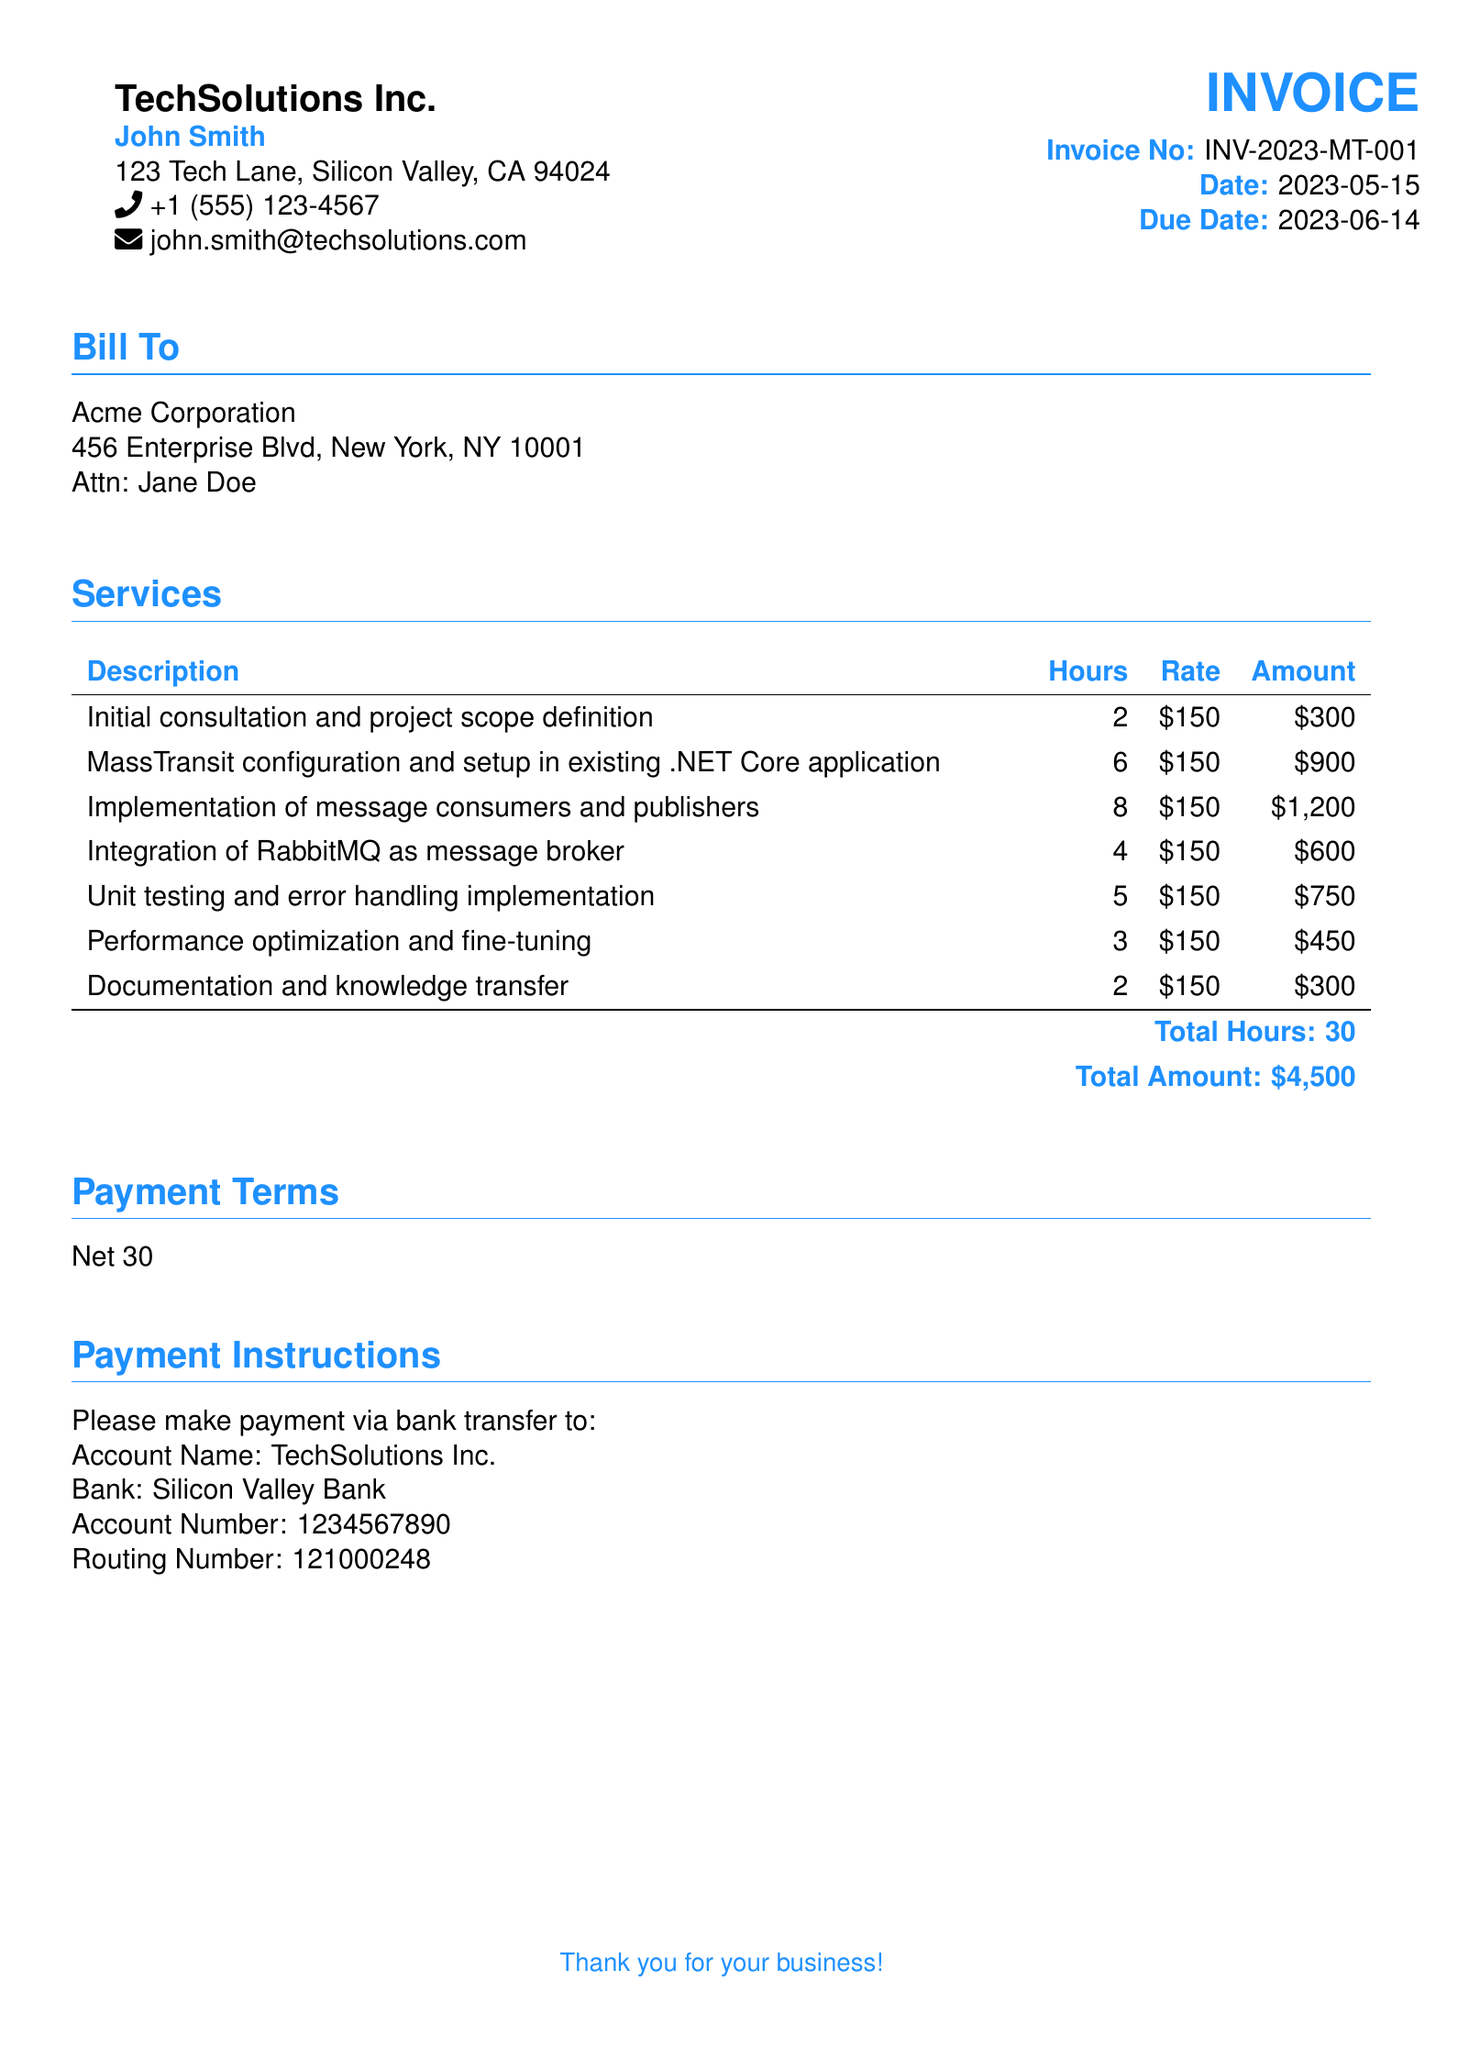What is the total amount? The total amount is explicitly stated in the document under the services section, which sums to four thousand five hundred dollars.
Answer: $4,500 Who is the contact person for Acme Corporation? The document specifies Jane Doe as the contact person for Acme Corporation in the "Bill To" section.
Answer: Jane Doe How many hours were spent on MassTransit configuration and setup? The hours for MassTransit configuration and setup are clearly listed in the services table as six hours.
Answer: 6 What is the invoice number? The invoice number is provided at the top of the document, which is used for tracking purposes; it reads INV-2023-MT-001.
Answer: INV-2023-MT-001 What is the due date for the invoice? The due date is mentioned near the top of the document and provides a timeframe for payment, specifically listing June 14, 2023.
Answer: 2023-06-14 Which service took the most hours to complete? By analyzing the services section, the implementation of message consumers and publishers is noted to take eight hours, the most compared to others.
Answer: Implementation of message consumers and publishers What payment terms are stated in the invoice? The document specifies the payment terms, which outline the duration until payment is due; it states Net 30.
Answer: Net 30 How many total hours were billed? The total hours are summed up in the services section of the document, which indicates thirty hours in total.
Answer: 30 What type of services were provided? The services provided are listed clearly under the services section, including consulting and technical support activities relevant to MassTransit.
Answer: Consulting services 